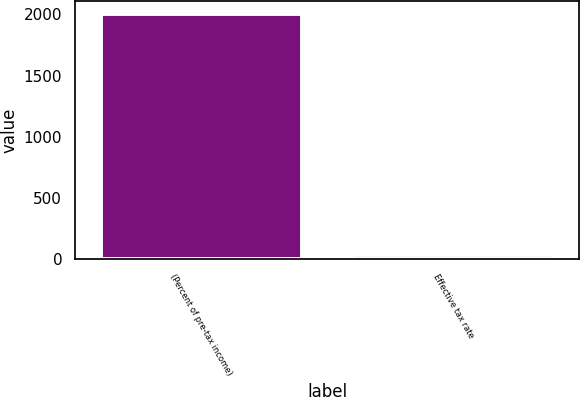Convert chart. <chart><loc_0><loc_0><loc_500><loc_500><bar_chart><fcel>(Percent of pre-tax income)<fcel>Effective tax rate<nl><fcel>2007<fcel>32.1<nl></chart> 